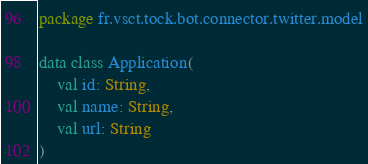Convert code to text. <code><loc_0><loc_0><loc_500><loc_500><_Kotlin_>package fr.vsct.tock.bot.connector.twitter.model

data class Application(
    val id: String,
    val name: String,
    val url: String
)</code> 